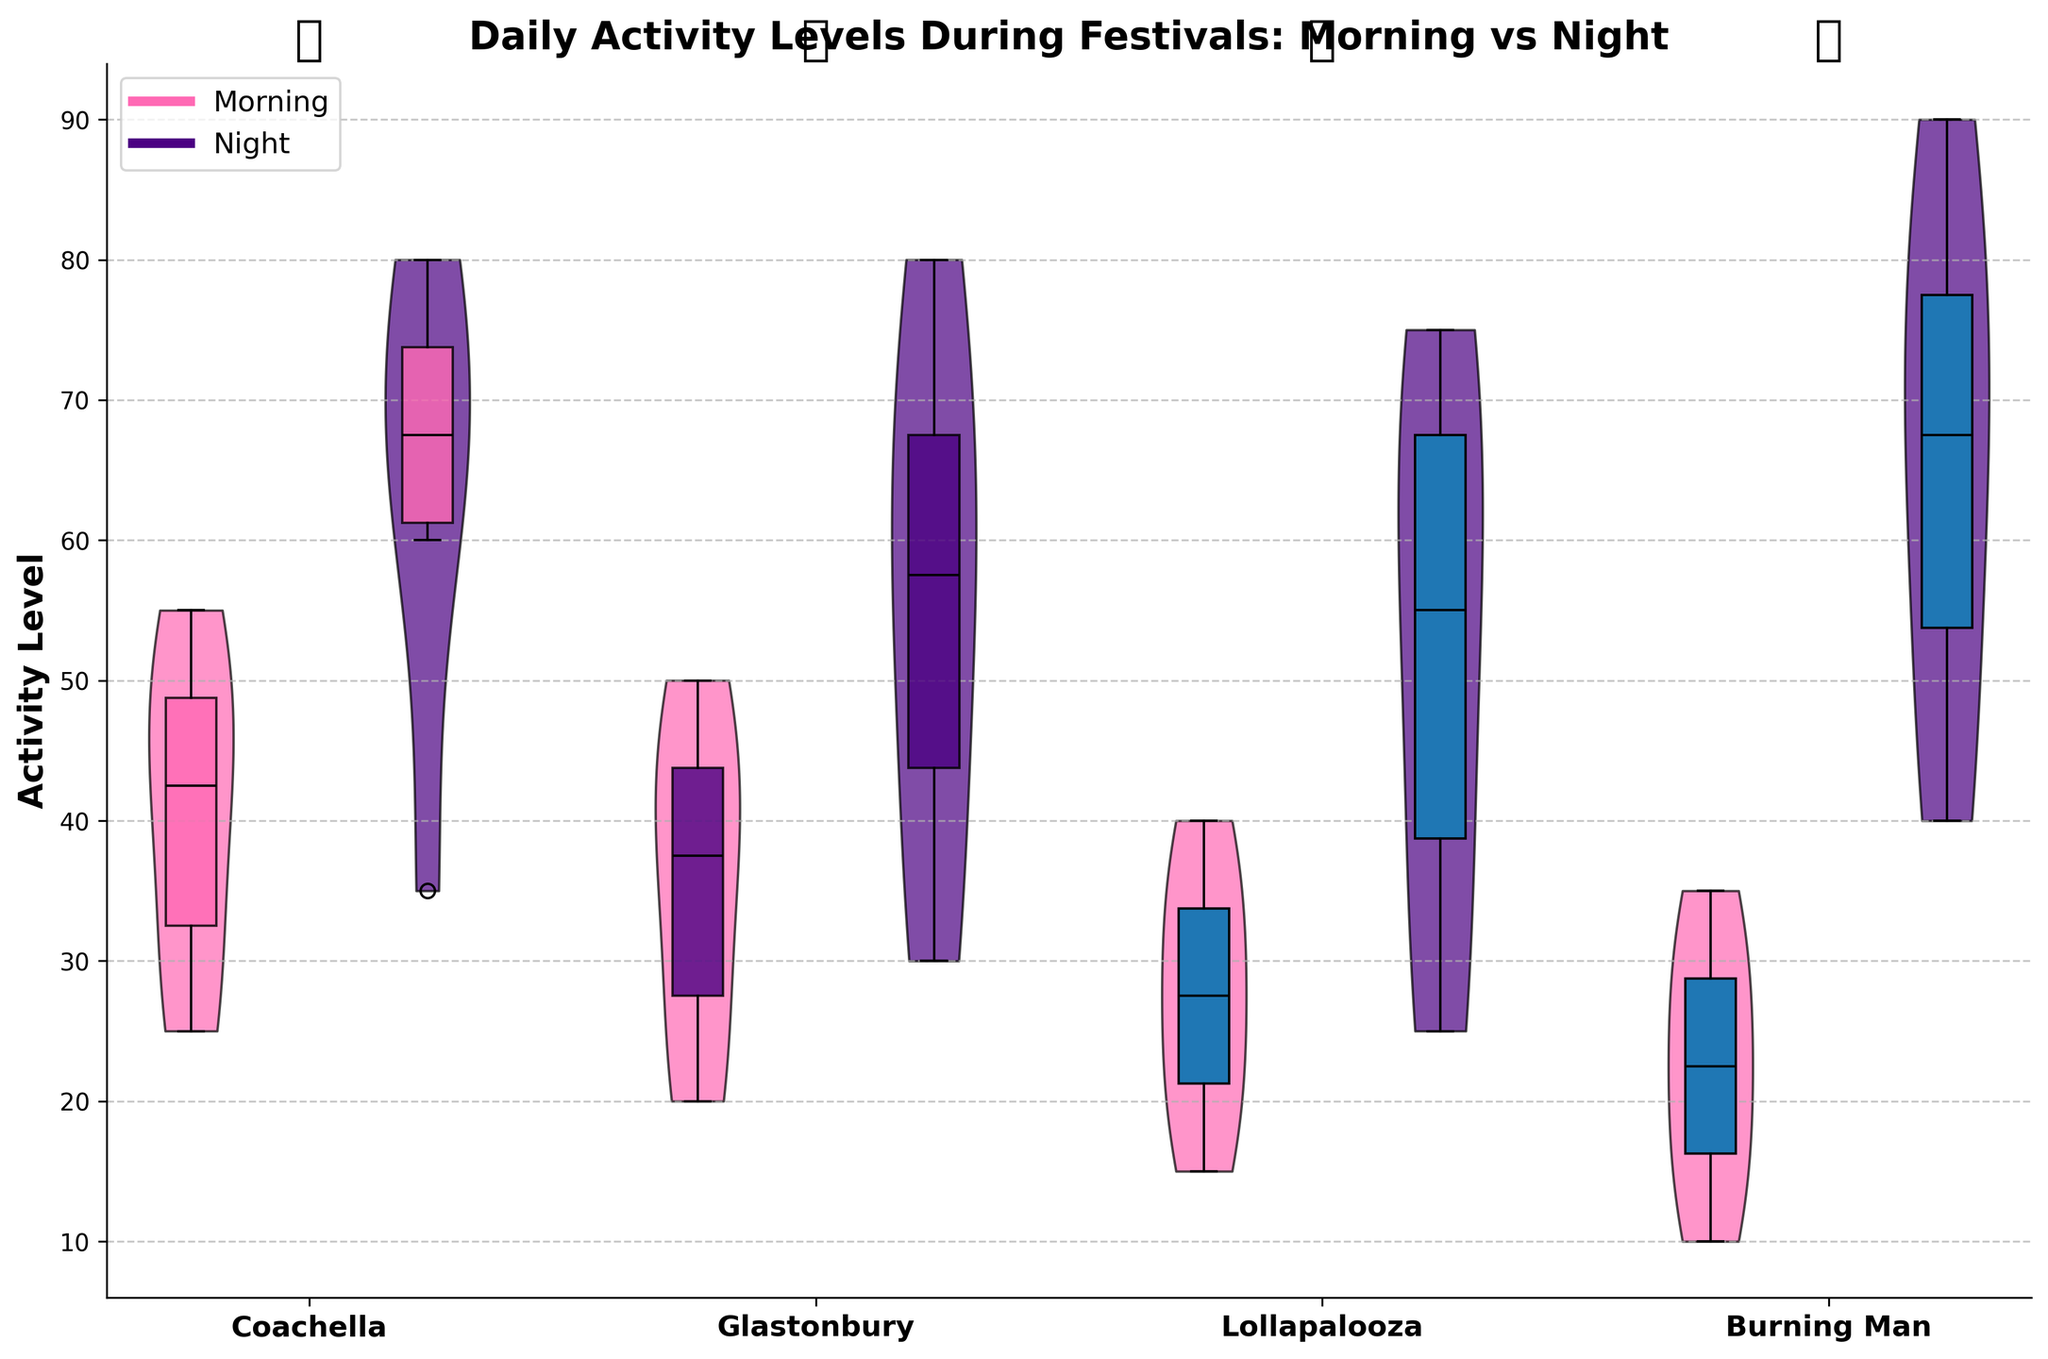What is the title of the plot? The title of the plot is displayed at the top and reads, "Daily Activity Levels During Festivals: Morning vs Night"
Answer: Daily Activity Levels During Festivals: Morning vs Night Which festival has the highest activity level at night? The festival with the highest activity level at night is identified by the position of the highest point of the violin plot for nighttime activity. Burning Man shows the highest activity level at night with a top activity level of 90.
Answer: Burning Man What are the colors used to represent morning and night activity levels? The plot uses two different colors for the activity levels: pink for morning and indigo for night, as indicated in the legend and the corresponding violin and box plots.
Answer: Pink (morning) and Indigo (night) Do mornings or nights generally have higher activity levels at Coachella? By comparing the positions of the median lines and the overall range of the violin plots for Coachella, it's clear that the night activity levels are higher, with medians and top activity levels of 75 and above.
Answer: Nights What is the median activity level for mornings at Glastonbury? The median activity level for mornings at Glastonbury is determined by the horizontal line in the center of the morning box plot for that festival. It aligns with the value of 35.
Answer: 35 Compare the range of activity levels for Burning Man in the morning and at night. The range of activity levels for each time period can be found by looking at the extent of the violin and box plots. Burning Man in the morning ranges from 10 to 35, while at night it ranges from 40 to 90, showing a broader range and higher values at night.
Answer: Morning: 10-35, Night: 40-90 Which festival has the smallest difference in the median activity levels between morning and night? To determine the smallest difference in median activity levels, compare the median lines in the box plots for each festival. Lollapalooza shows the smallest difference, with medians approximately at 27.5 (morning) and 45 (night), giving a difference of 17.5.
Answer: Lollapalooza What festival shows the highest variability in morning activity levels? The festival with the highest variability in morning activity levels is identified by the width and spread of the morning violin plot. Coachella's morning activity levels appear to have the widest spread and variability.
Answer: Coachella 